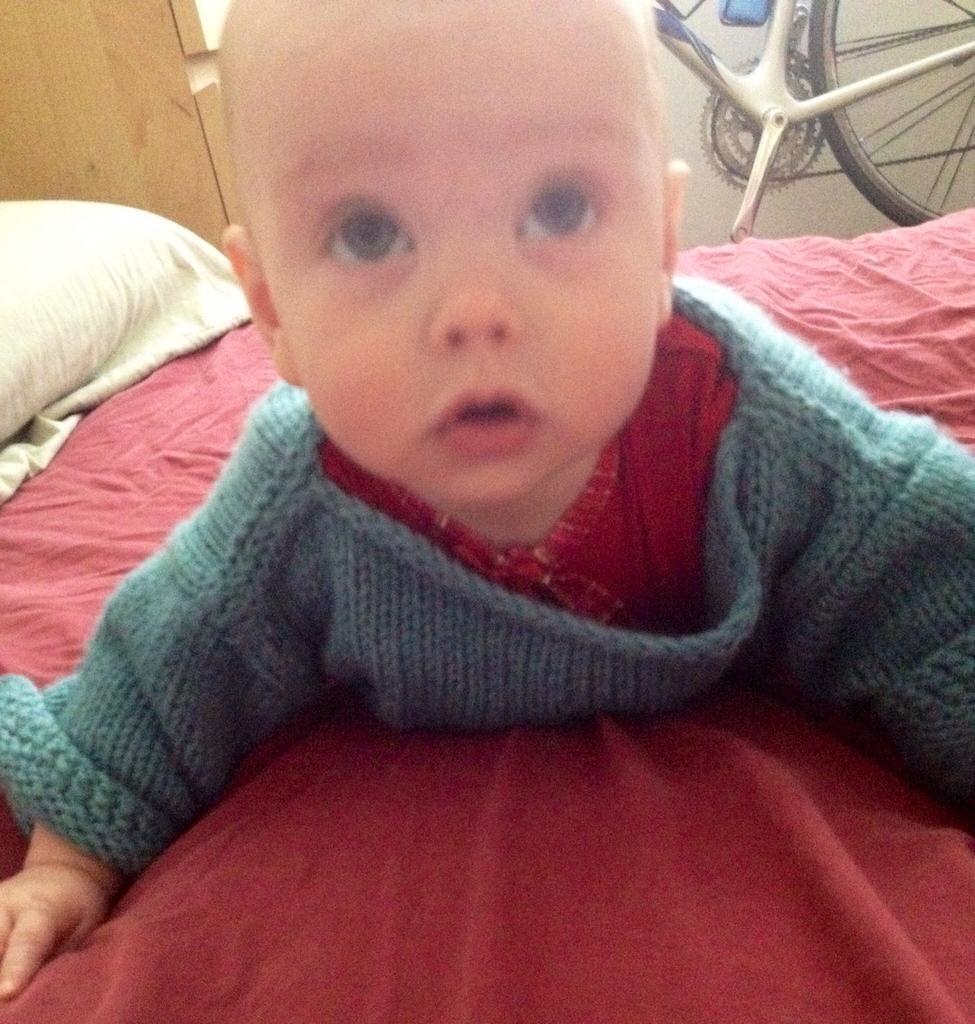Can you describe this image briefly? In the image we can see a baby lying on the bed and the baby is wearing clothes. Here we can see the bad and the pillow. We can even see the bicycle. 